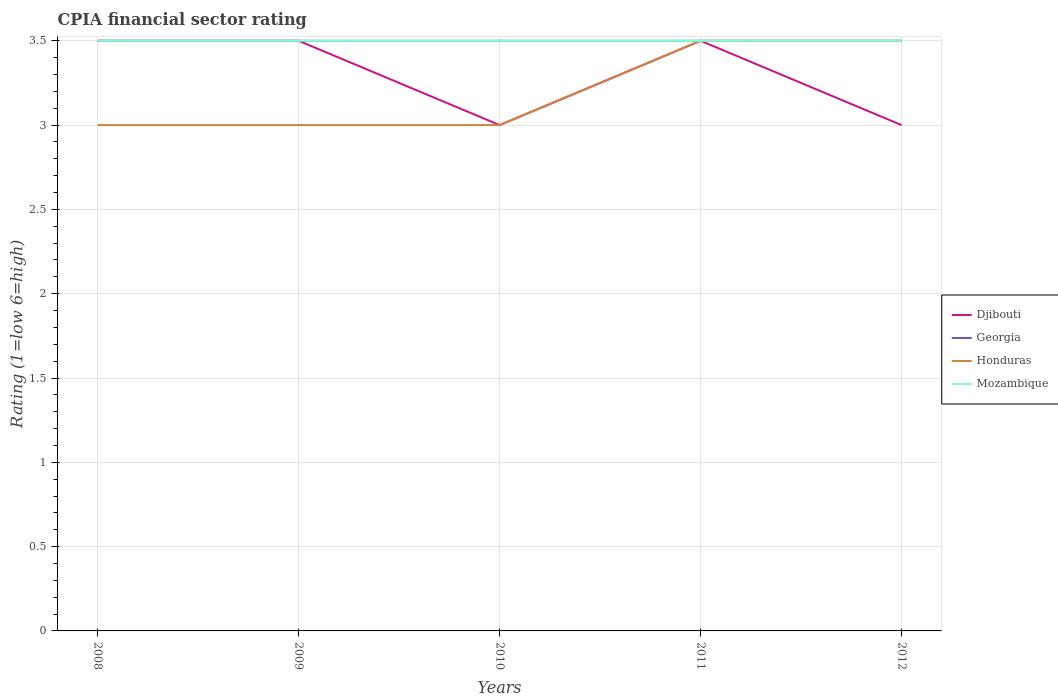Does the line corresponding to Georgia intersect with the line corresponding to Djibouti?
Make the answer very short. Yes. Is the number of lines equal to the number of legend labels?
Ensure brevity in your answer.  Yes. Across all years, what is the maximum CPIA rating in Honduras?
Provide a short and direct response. 3. In which year was the CPIA rating in Mozambique maximum?
Provide a short and direct response. 2008. What is the total CPIA rating in Mozambique in the graph?
Offer a very short reply. 0. What is the difference between the highest and the second highest CPIA rating in Georgia?
Provide a succinct answer. 0. What is the difference between the highest and the lowest CPIA rating in Georgia?
Provide a succinct answer. 0. Is the CPIA rating in Georgia strictly greater than the CPIA rating in Djibouti over the years?
Make the answer very short. No. How many lines are there?
Keep it short and to the point. 4. Are the values on the major ticks of Y-axis written in scientific E-notation?
Make the answer very short. No. Does the graph contain any zero values?
Offer a very short reply. No. Does the graph contain grids?
Keep it short and to the point. Yes. Where does the legend appear in the graph?
Make the answer very short. Center right. How are the legend labels stacked?
Offer a terse response. Vertical. What is the title of the graph?
Offer a very short reply. CPIA financial sector rating. Does "Israel" appear as one of the legend labels in the graph?
Your answer should be compact. No. What is the Rating (1=low 6=high) of Georgia in 2009?
Your answer should be very brief. 3.5. What is the Rating (1=low 6=high) of Honduras in 2009?
Offer a very short reply. 3. What is the Rating (1=low 6=high) in Honduras in 2010?
Your answer should be very brief. 3. What is the Rating (1=low 6=high) in Georgia in 2011?
Make the answer very short. 3.5. What is the Rating (1=low 6=high) in Mozambique in 2011?
Keep it short and to the point. 3.5. What is the Rating (1=low 6=high) of Djibouti in 2012?
Your answer should be very brief. 3. What is the Rating (1=low 6=high) of Honduras in 2012?
Offer a very short reply. 3.5. What is the Rating (1=low 6=high) in Mozambique in 2012?
Your response must be concise. 3.5. Across all years, what is the maximum Rating (1=low 6=high) in Djibouti?
Provide a succinct answer. 3.5. Across all years, what is the maximum Rating (1=low 6=high) of Honduras?
Ensure brevity in your answer.  3.5. Across all years, what is the minimum Rating (1=low 6=high) in Djibouti?
Ensure brevity in your answer.  3. Across all years, what is the minimum Rating (1=low 6=high) in Mozambique?
Give a very brief answer. 3.5. What is the total Rating (1=low 6=high) of Georgia in the graph?
Provide a succinct answer. 17.5. What is the total Rating (1=low 6=high) in Honduras in the graph?
Ensure brevity in your answer.  16. What is the difference between the Rating (1=low 6=high) in Honduras in 2008 and that in 2009?
Your response must be concise. 0. What is the difference between the Rating (1=low 6=high) of Mozambique in 2008 and that in 2009?
Your response must be concise. 0. What is the difference between the Rating (1=low 6=high) in Djibouti in 2008 and that in 2010?
Your response must be concise. 0.5. What is the difference between the Rating (1=low 6=high) in Georgia in 2008 and that in 2010?
Offer a terse response. 0. What is the difference between the Rating (1=low 6=high) of Honduras in 2008 and that in 2010?
Provide a succinct answer. 0. What is the difference between the Rating (1=low 6=high) in Mozambique in 2008 and that in 2010?
Your response must be concise. 0. What is the difference between the Rating (1=low 6=high) in Djibouti in 2008 and that in 2011?
Offer a terse response. 0. What is the difference between the Rating (1=low 6=high) of Georgia in 2008 and that in 2011?
Provide a succinct answer. 0. What is the difference between the Rating (1=low 6=high) of Honduras in 2008 and that in 2011?
Give a very brief answer. -0.5. What is the difference between the Rating (1=low 6=high) of Mozambique in 2008 and that in 2012?
Your response must be concise. 0. What is the difference between the Rating (1=low 6=high) in Djibouti in 2009 and that in 2010?
Provide a short and direct response. 0.5. What is the difference between the Rating (1=low 6=high) in Honduras in 2009 and that in 2010?
Offer a very short reply. 0. What is the difference between the Rating (1=low 6=high) in Georgia in 2009 and that in 2012?
Your response must be concise. 0. What is the difference between the Rating (1=low 6=high) in Djibouti in 2010 and that in 2011?
Give a very brief answer. -0.5. What is the difference between the Rating (1=low 6=high) of Georgia in 2010 and that in 2011?
Offer a terse response. 0. What is the difference between the Rating (1=low 6=high) of Honduras in 2010 and that in 2011?
Keep it short and to the point. -0.5. What is the difference between the Rating (1=low 6=high) of Djibouti in 2010 and that in 2012?
Keep it short and to the point. 0. What is the difference between the Rating (1=low 6=high) of Georgia in 2010 and that in 2012?
Provide a succinct answer. 0. What is the difference between the Rating (1=low 6=high) of Honduras in 2010 and that in 2012?
Ensure brevity in your answer.  -0.5. What is the difference between the Rating (1=low 6=high) of Mozambique in 2010 and that in 2012?
Make the answer very short. 0. What is the difference between the Rating (1=low 6=high) in Djibouti in 2011 and that in 2012?
Keep it short and to the point. 0.5. What is the difference between the Rating (1=low 6=high) of Honduras in 2011 and that in 2012?
Keep it short and to the point. 0. What is the difference between the Rating (1=low 6=high) in Djibouti in 2008 and the Rating (1=low 6=high) in Georgia in 2009?
Give a very brief answer. 0. What is the difference between the Rating (1=low 6=high) in Djibouti in 2008 and the Rating (1=low 6=high) in Honduras in 2009?
Ensure brevity in your answer.  0.5. What is the difference between the Rating (1=low 6=high) in Djibouti in 2008 and the Rating (1=low 6=high) in Mozambique in 2009?
Ensure brevity in your answer.  0. What is the difference between the Rating (1=low 6=high) in Georgia in 2008 and the Rating (1=low 6=high) in Mozambique in 2009?
Provide a succinct answer. 0. What is the difference between the Rating (1=low 6=high) in Djibouti in 2008 and the Rating (1=low 6=high) in Georgia in 2010?
Provide a short and direct response. 0. What is the difference between the Rating (1=low 6=high) in Djibouti in 2008 and the Rating (1=low 6=high) in Mozambique in 2010?
Give a very brief answer. 0. What is the difference between the Rating (1=low 6=high) of Georgia in 2008 and the Rating (1=low 6=high) of Honduras in 2010?
Give a very brief answer. 0.5. What is the difference between the Rating (1=low 6=high) in Georgia in 2008 and the Rating (1=low 6=high) in Mozambique in 2010?
Make the answer very short. 0. What is the difference between the Rating (1=low 6=high) in Honduras in 2008 and the Rating (1=low 6=high) in Mozambique in 2010?
Keep it short and to the point. -0.5. What is the difference between the Rating (1=low 6=high) in Djibouti in 2008 and the Rating (1=low 6=high) in Honduras in 2011?
Offer a very short reply. 0. What is the difference between the Rating (1=low 6=high) of Honduras in 2008 and the Rating (1=low 6=high) of Mozambique in 2011?
Provide a succinct answer. -0.5. What is the difference between the Rating (1=low 6=high) in Djibouti in 2008 and the Rating (1=low 6=high) in Mozambique in 2012?
Provide a succinct answer. 0. What is the difference between the Rating (1=low 6=high) of Georgia in 2008 and the Rating (1=low 6=high) of Honduras in 2012?
Your answer should be compact. 0. What is the difference between the Rating (1=low 6=high) in Georgia in 2008 and the Rating (1=low 6=high) in Mozambique in 2012?
Your answer should be compact. 0. What is the difference between the Rating (1=low 6=high) of Djibouti in 2009 and the Rating (1=low 6=high) of Honduras in 2010?
Your response must be concise. 0.5. What is the difference between the Rating (1=low 6=high) of Georgia in 2009 and the Rating (1=low 6=high) of Honduras in 2010?
Offer a terse response. 0.5. What is the difference between the Rating (1=low 6=high) in Georgia in 2009 and the Rating (1=low 6=high) in Mozambique in 2010?
Make the answer very short. 0. What is the difference between the Rating (1=low 6=high) in Djibouti in 2009 and the Rating (1=low 6=high) in Honduras in 2011?
Provide a short and direct response. 0. What is the difference between the Rating (1=low 6=high) of Djibouti in 2009 and the Rating (1=low 6=high) of Mozambique in 2011?
Give a very brief answer. 0. What is the difference between the Rating (1=low 6=high) in Georgia in 2009 and the Rating (1=low 6=high) in Mozambique in 2011?
Provide a succinct answer. 0. What is the difference between the Rating (1=low 6=high) in Honduras in 2009 and the Rating (1=low 6=high) in Mozambique in 2011?
Provide a succinct answer. -0.5. What is the difference between the Rating (1=low 6=high) in Djibouti in 2009 and the Rating (1=low 6=high) in Honduras in 2012?
Your response must be concise. 0. What is the difference between the Rating (1=low 6=high) in Georgia in 2009 and the Rating (1=low 6=high) in Mozambique in 2012?
Keep it short and to the point. 0. What is the difference between the Rating (1=low 6=high) in Honduras in 2009 and the Rating (1=low 6=high) in Mozambique in 2012?
Ensure brevity in your answer.  -0.5. What is the difference between the Rating (1=low 6=high) in Djibouti in 2010 and the Rating (1=low 6=high) in Georgia in 2011?
Your answer should be very brief. -0.5. What is the difference between the Rating (1=low 6=high) in Djibouti in 2010 and the Rating (1=low 6=high) in Honduras in 2011?
Your response must be concise. -0.5. What is the difference between the Rating (1=low 6=high) of Djibouti in 2010 and the Rating (1=low 6=high) of Mozambique in 2011?
Provide a short and direct response. -0.5. What is the difference between the Rating (1=low 6=high) in Georgia in 2010 and the Rating (1=low 6=high) in Mozambique in 2011?
Keep it short and to the point. 0. What is the difference between the Rating (1=low 6=high) in Djibouti in 2010 and the Rating (1=low 6=high) in Honduras in 2012?
Your answer should be compact. -0.5. What is the difference between the Rating (1=low 6=high) of Georgia in 2010 and the Rating (1=low 6=high) of Honduras in 2012?
Make the answer very short. 0. What is the difference between the Rating (1=low 6=high) in Georgia in 2010 and the Rating (1=low 6=high) in Mozambique in 2012?
Give a very brief answer. 0. What is the difference between the Rating (1=low 6=high) of Honduras in 2010 and the Rating (1=low 6=high) of Mozambique in 2012?
Give a very brief answer. -0.5. What is the difference between the Rating (1=low 6=high) in Djibouti in 2011 and the Rating (1=low 6=high) in Georgia in 2012?
Provide a short and direct response. 0. What is the difference between the Rating (1=low 6=high) of Djibouti in 2011 and the Rating (1=low 6=high) of Honduras in 2012?
Your answer should be compact. 0. What is the difference between the Rating (1=low 6=high) in Georgia in 2011 and the Rating (1=low 6=high) in Honduras in 2012?
Offer a terse response. 0. What is the difference between the Rating (1=low 6=high) of Georgia in 2011 and the Rating (1=low 6=high) of Mozambique in 2012?
Provide a short and direct response. 0. What is the difference between the Rating (1=low 6=high) in Honduras in 2011 and the Rating (1=low 6=high) in Mozambique in 2012?
Give a very brief answer. 0. What is the average Rating (1=low 6=high) in Djibouti per year?
Keep it short and to the point. 3.3. In the year 2008, what is the difference between the Rating (1=low 6=high) of Djibouti and Rating (1=low 6=high) of Georgia?
Keep it short and to the point. 0. In the year 2008, what is the difference between the Rating (1=low 6=high) of Georgia and Rating (1=low 6=high) of Honduras?
Offer a very short reply. 0.5. In the year 2008, what is the difference between the Rating (1=low 6=high) in Georgia and Rating (1=low 6=high) in Mozambique?
Your answer should be compact. 0. In the year 2008, what is the difference between the Rating (1=low 6=high) in Honduras and Rating (1=low 6=high) in Mozambique?
Your answer should be compact. -0.5. In the year 2009, what is the difference between the Rating (1=low 6=high) in Djibouti and Rating (1=low 6=high) in Georgia?
Provide a succinct answer. 0. In the year 2009, what is the difference between the Rating (1=low 6=high) of Djibouti and Rating (1=low 6=high) of Honduras?
Make the answer very short. 0.5. In the year 2010, what is the difference between the Rating (1=low 6=high) in Djibouti and Rating (1=low 6=high) in Mozambique?
Your answer should be very brief. -0.5. In the year 2010, what is the difference between the Rating (1=low 6=high) in Georgia and Rating (1=low 6=high) in Mozambique?
Offer a very short reply. 0. In the year 2011, what is the difference between the Rating (1=low 6=high) of Djibouti and Rating (1=low 6=high) of Georgia?
Your answer should be very brief. 0. In the year 2011, what is the difference between the Rating (1=low 6=high) in Djibouti and Rating (1=low 6=high) in Honduras?
Make the answer very short. 0. In the year 2011, what is the difference between the Rating (1=low 6=high) of Djibouti and Rating (1=low 6=high) of Mozambique?
Your answer should be very brief. 0. In the year 2011, what is the difference between the Rating (1=low 6=high) in Georgia and Rating (1=low 6=high) in Mozambique?
Your response must be concise. 0. In the year 2011, what is the difference between the Rating (1=low 6=high) in Honduras and Rating (1=low 6=high) in Mozambique?
Make the answer very short. 0. In the year 2012, what is the difference between the Rating (1=low 6=high) in Djibouti and Rating (1=low 6=high) in Georgia?
Give a very brief answer. -0.5. In the year 2012, what is the difference between the Rating (1=low 6=high) of Djibouti and Rating (1=low 6=high) of Honduras?
Offer a terse response. -0.5. In the year 2012, what is the difference between the Rating (1=low 6=high) in Djibouti and Rating (1=low 6=high) in Mozambique?
Your answer should be very brief. -0.5. In the year 2012, what is the difference between the Rating (1=low 6=high) of Georgia and Rating (1=low 6=high) of Honduras?
Give a very brief answer. 0. In the year 2012, what is the difference between the Rating (1=low 6=high) in Georgia and Rating (1=low 6=high) in Mozambique?
Ensure brevity in your answer.  0. In the year 2012, what is the difference between the Rating (1=low 6=high) of Honduras and Rating (1=low 6=high) of Mozambique?
Provide a succinct answer. 0. What is the ratio of the Rating (1=low 6=high) of Honduras in 2008 to that in 2011?
Offer a very short reply. 0.86. What is the ratio of the Rating (1=low 6=high) of Djibouti in 2008 to that in 2012?
Provide a succinct answer. 1.17. What is the ratio of the Rating (1=low 6=high) in Mozambique in 2008 to that in 2012?
Provide a succinct answer. 1. What is the ratio of the Rating (1=low 6=high) of Djibouti in 2009 to that in 2010?
Your answer should be very brief. 1.17. What is the ratio of the Rating (1=low 6=high) in Georgia in 2009 to that in 2010?
Offer a terse response. 1. What is the ratio of the Rating (1=low 6=high) in Honduras in 2009 to that in 2010?
Your response must be concise. 1. What is the ratio of the Rating (1=low 6=high) of Djibouti in 2009 to that in 2011?
Your response must be concise. 1. What is the ratio of the Rating (1=low 6=high) of Georgia in 2009 to that in 2011?
Provide a succinct answer. 1. What is the ratio of the Rating (1=low 6=high) of Honduras in 2009 to that in 2011?
Provide a short and direct response. 0.86. What is the ratio of the Rating (1=low 6=high) of Djibouti in 2009 to that in 2012?
Your response must be concise. 1.17. What is the ratio of the Rating (1=low 6=high) in Georgia in 2009 to that in 2012?
Give a very brief answer. 1. What is the ratio of the Rating (1=low 6=high) of Honduras in 2009 to that in 2012?
Provide a succinct answer. 0.86. What is the ratio of the Rating (1=low 6=high) in Mozambique in 2009 to that in 2012?
Your answer should be compact. 1. What is the ratio of the Rating (1=low 6=high) of Mozambique in 2010 to that in 2011?
Provide a short and direct response. 1. What is the ratio of the Rating (1=low 6=high) in Djibouti in 2010 to that in 2012?
Make the answer very short. 1. What is the ratio of the Rating (1=low 6=high) in Mozambique in 2010 to that in 2012?
Offer a very short reply. 1. What is the difference between the highest and the second highest Rating (1=low 6=high) in Mozambique?
Give a very brief answer. 0. What is the difference between the highest and the lowest Rating (1=low 6=high) of Djibouti?
Your answer should be compact. 0.5. What is the difference between the highest and the lowest Rating (1=low 6=high) in Mozambique?
Ensure brevity in your answer.  0. 